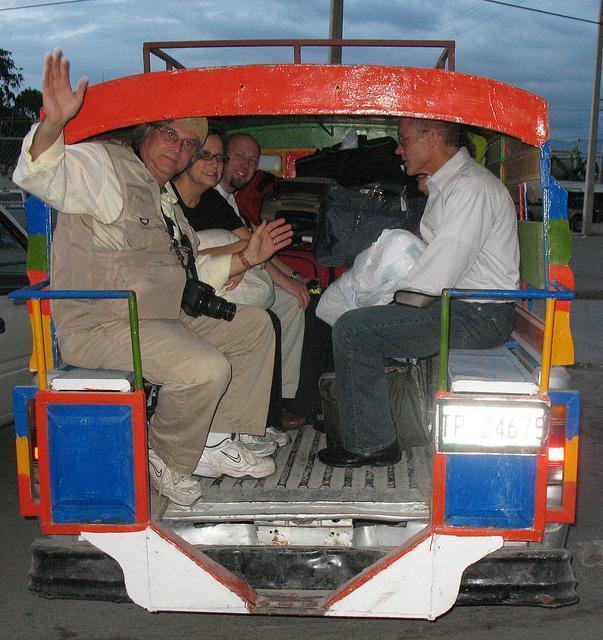How many people are in the vehicle?
Give a very brief answer. 5. How many people can be seen?
Give a very brief answer. 4. How many suitcases can be seen?
Give a very brief answer. 2. How many boats are to the right of the stop sign?
Give a very brief answer. 0. 